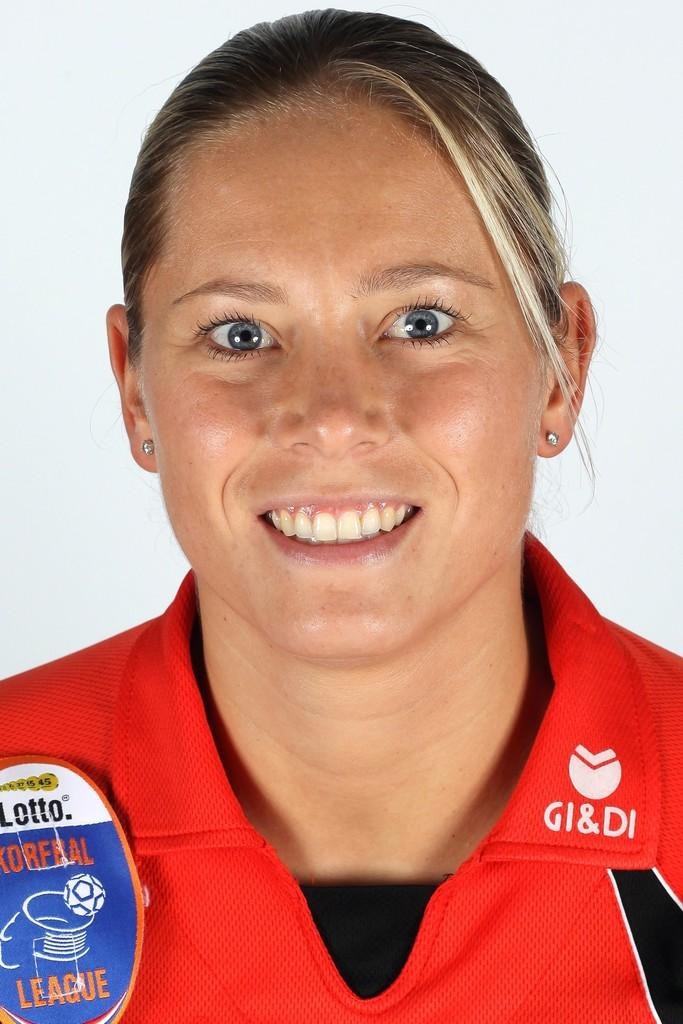<image>
Share a concise interpretation of the image provided. A smiling blond woman with blue eyes wearing a red jersey for the Korfbal Leauge. 